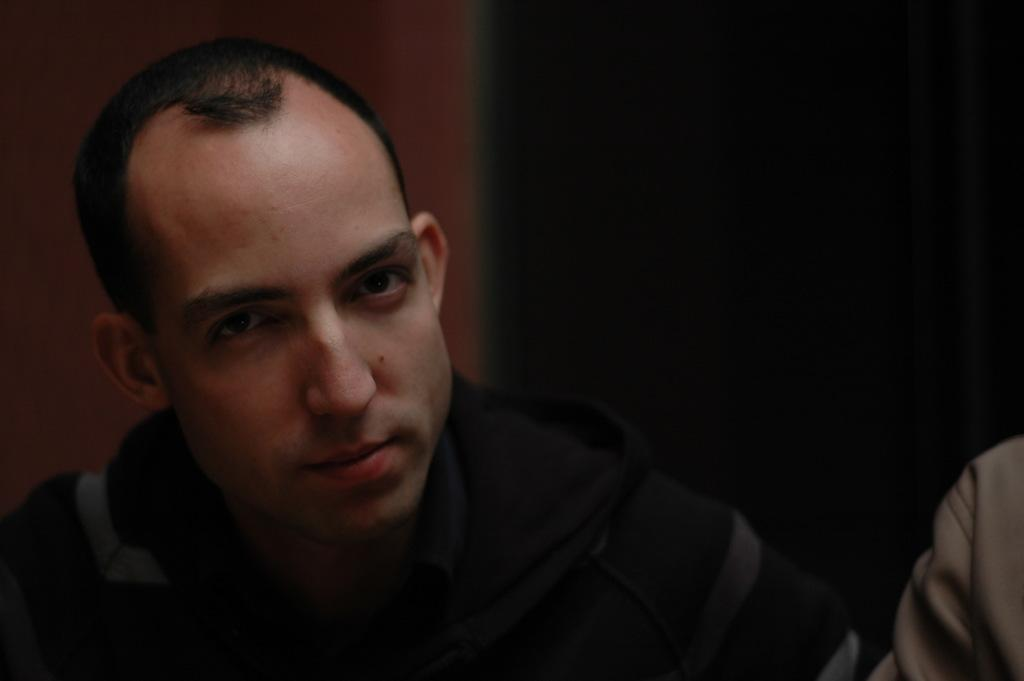Who is present in the image? There is a man in the image. Where is the man located in the image? The man is towards the left side of the image. What is the man wearing in the image? The man is wearing a black jacket. Is there anyone else in the image besides the man? Yes, there is another person beside the man. What type of power does the man have in the image? There is no indication of any power or authority the man might have in the image. 